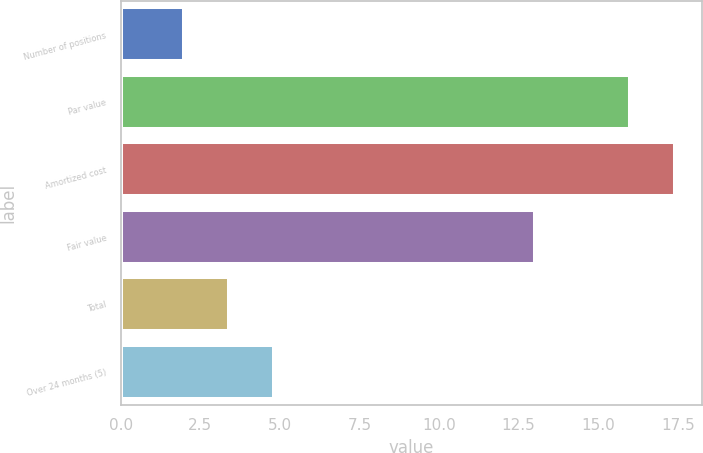Convert chart to OTSL. <chart><loc_0><loc_0><loc_500><loc_500><bar_chart><fcel>Number of positions<fcel>Par value<fcel>Amortized cost<fcel>Fair value<fcel>Total<fcel>Over 24 months (5)<nl><fcel>2<fcel>16<fcel>17.4<fcel>13<fcel>3.4<fcel>4.8<nl></chart> 